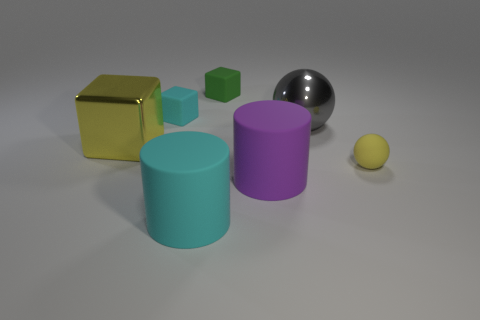Subtract all small blocks. How many blocks are left? 1 Add 1 large metal things. How many objects exist? 8 Subtract 1 cubes. How many cubes are left? 2 Subtract all green cubes. How many cubes are left? 2 Add 3 large yellow objects. How many large yellow objects exist? 4 Subtract 0 green spheres. How many objects are left? 7 Subtract all spheres. How many objects are left? 5 Subtract all brown cylinders. Subtract all gray balls. How many cylinders are left? 2 Subtract all green blocks. Subtract all yellow metal objects. How many objects are left? 5 Add 1 yellow metal blocks. How many yellow metal blocks are left? 2 